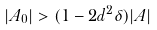<formula> <loc_0><loc_0><loc_500><loc_500>| A _ { 0 } | > ( 1 - 2 d ^ { 2 } \delta ) | A |</formula> 